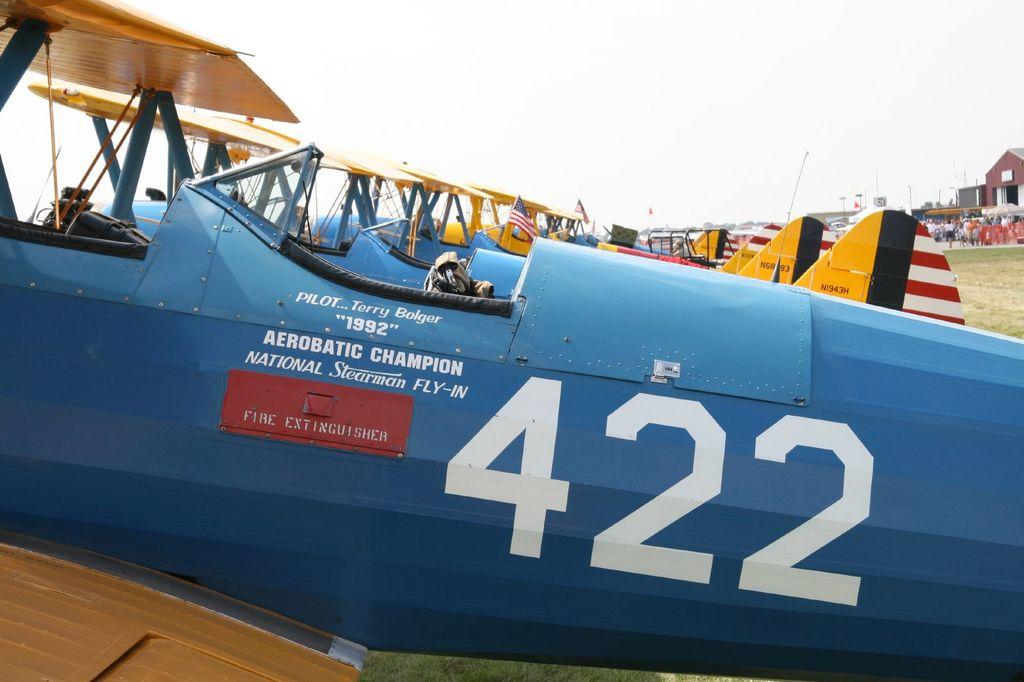What number is seen on the plane?
Provide a succinct answer. 422. Is the pilot named terry bolger?
Offer a terse response. Yes. 